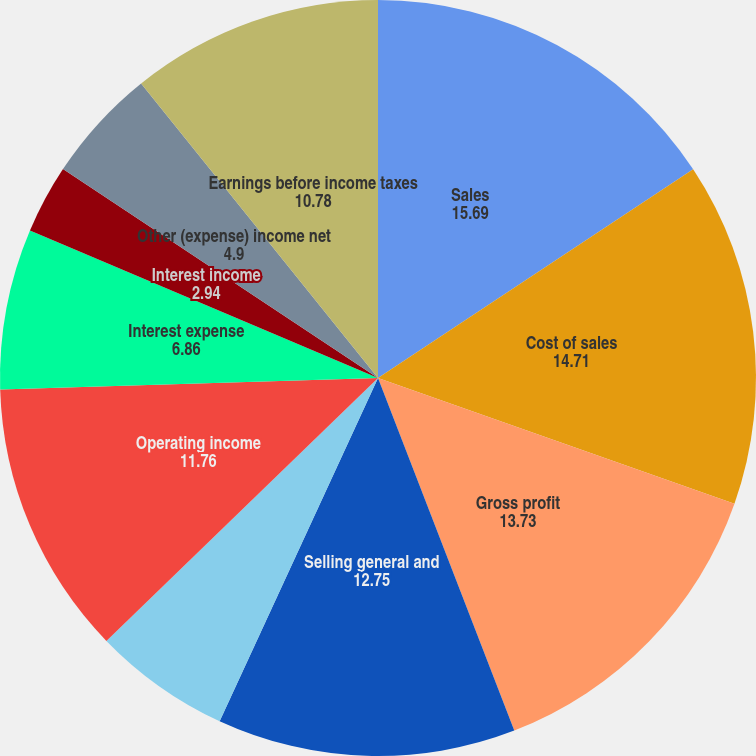Convert chart. <chart><loc_0><loc_0><loc_500><loc_500><pie_chart><fcel>Sales<fcel>Cost of sales<fcel>Gross profit<fcel>Selling general and<fcel>Net earnings from affiliates<fcel>Operating income<fcel>Interest expense<fcel>Interest income<fcel>Other (expense) income net<fcel>Earnings before income taxes<nl><fcel>15.69%<fcel>14.71%<fcel>13.73%<fcel>12.75%<fcel>5.88%<fcel>11.76%<fcel>6.86%<fcel>2.94%<fcel>4.9%<fcel>10.78%<nl></chart> 